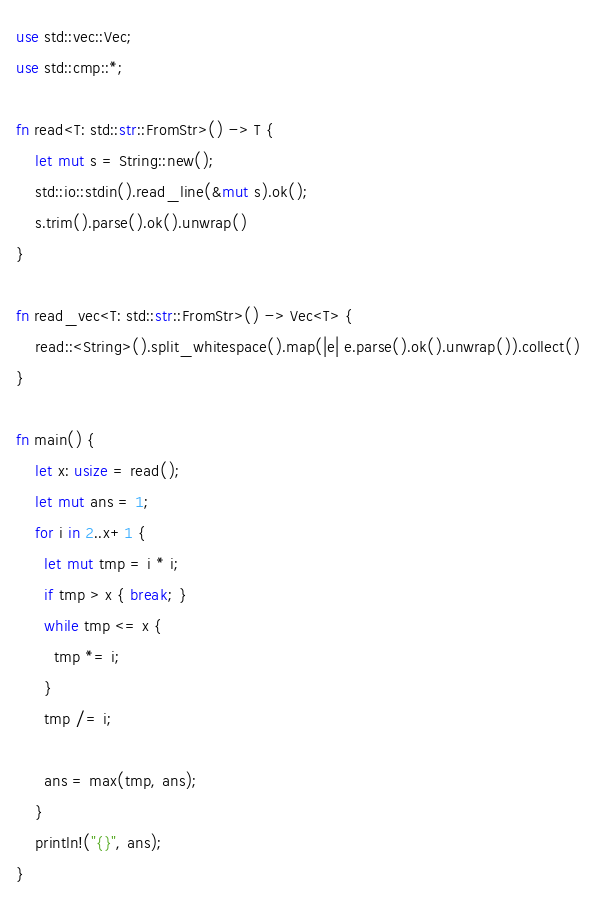Convert code to text. <code><loc_0><loc_0><loc_500><loc_500><_Rust_>use std::vec::Vec;
use std::cmp::*;

fn read<T: std::str::FromStr>() -> T {
    let mut s = String::new();
    std::io::stdin().read_line(&mut s).ok();
    s.trim().parse().ok().unwrap()
}

fn read_vec<T: std::str::FromStr>() -> Vec<T> {
    read::<String>().split_whitespace().map(|e| e.parse().ok().unwrap()).collect()
}

fn main() {
    let x: usize = read();
    let mut ans = 1;
    for i in 2..x+1 {
      let mut tmp = i * i;
      if tmp > x { break; }
      while tmp <= x {
        tmp *= i;
      }
      tmp /= i;

      ans = max(tmp, ans);
    }
    println!("{}", ans);
}
</code> 